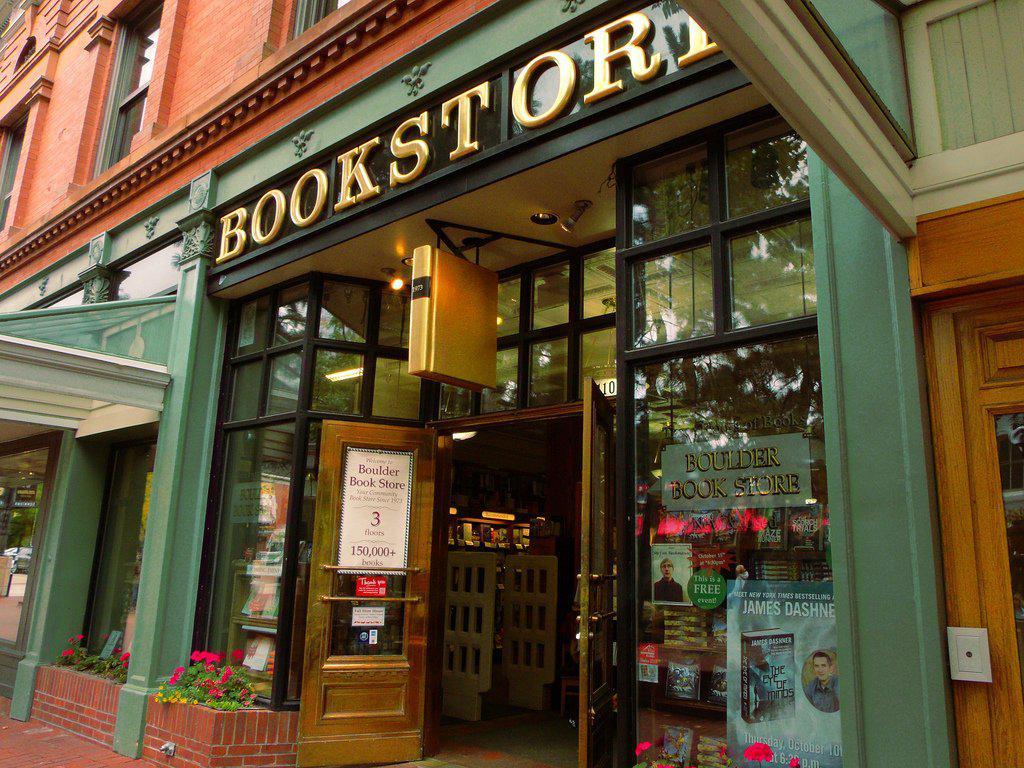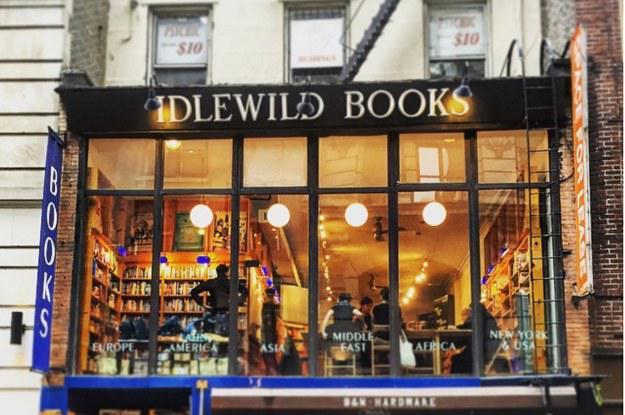The first image is the image on the left, the second image is the image on the right. For the images displayed, is the sentence "A bookstore has a curved staircase that leads to a higher floor." factually correct? Answer yes or no. No. The first image is the image on the left, the second image is the image on the right. Considering the images on both sides, is "The front of the bookstore is painted green." valid? Answer yes or no. Yes. 